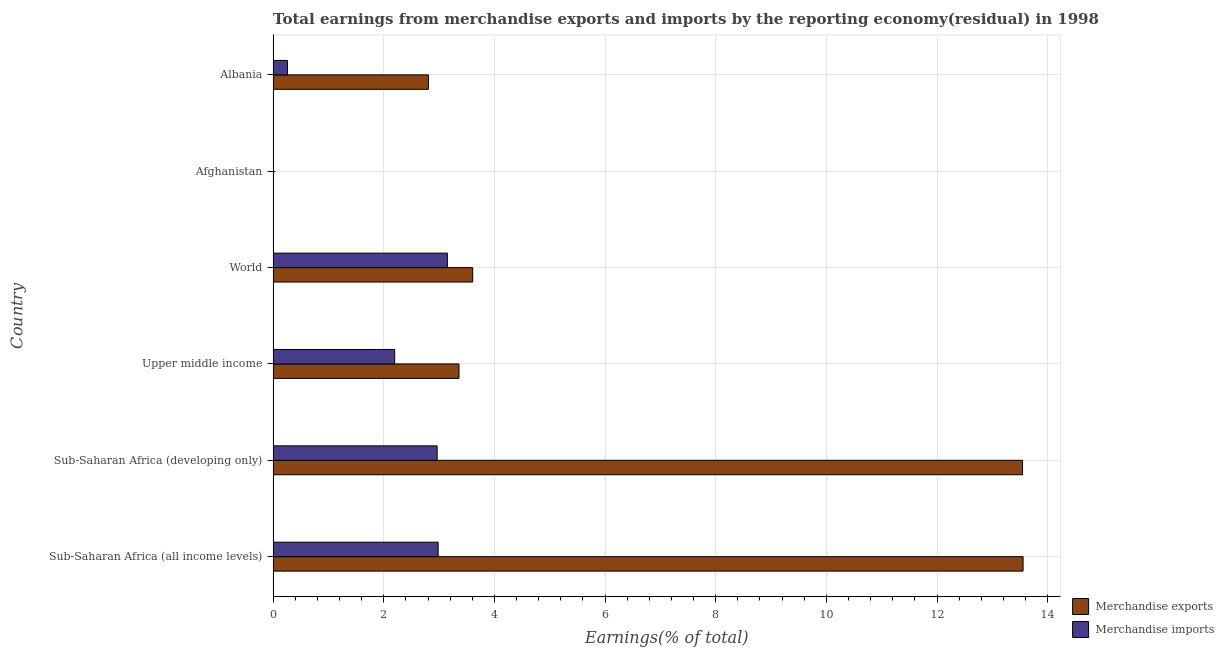How many different coloured bars are there?
Offer a very short reply. 2. Are the number of bars on each tick of the Y-axis equal?
Give a very brief answer. No. How many bars are there on the 4th tick from the top?
Provide a short and direct response. 2. How many bars are there on the 1st tick from the bottom?
Provide a succinct answer. 2. In how many cases, is the number of bars for a given country not equal to the number of legend labels?
Provide a short and direct response. 1. What is the earnings from merchandise imports in Sub-Saharan Africa (all income levels)?
Make the answer very short. 2.98. Across all countries, what is the maximum earnings from merchandise imports?
Keep it short and to the point. 3.15. What is the total earnings from merchandise exports in the graph?
Give a very brief answer. 36.88. What is the difference between the earnings from merchandise exports in Albania and that in World?
Offer a very short reply. -0.8. What is the difference between the earnings from merchandise exports in Sub-Saharan Africa (developing only) and the earnings from merchandise imports in Afghanistan?
Your answer should be very brief. 13.55. What is the average earnings from merchandise imports per country?
Keep it short and to the point. 1.93. What is the difference between the earnings from merchandise exports and earnings from merchandise imports in Sub-Saharan Africa (all income levels)?
Offer a terse response. 10.57. In how many countries, is the earnings from merchandise imports greater than 1.2000000000000002 %?
Offer a terse response. 4. What is the ratio of the earnings from merchandise imports in Sub-Saharan Africa (developing only) to that in Upper middle income?
Your answer should be very brief. 1.35. Is the earnings from merchandise exports in Albania less than that in World?
Your answer should be very brief. Yes. Is the difference between the earnings from merchandise imports in Albania and World greater than the difference between the earnings from merchandise exports in Albania and World?
Provide a short and direct response. No. What is the difference between the highest and the second highest earnings from merchandise exports?
Your answer should be very brief. 0.01. What is the difference between the highest and the lowest earnings from merchandise imports?
Provide a succinct answer. 3.15. What is the difference between two consecutive major ticks on the X-axis?
Ensure brevity in your answer.  2. Are the values on the major ticks of X-axis written in scientific E-notation?
Give a very brief answer. No. How are the legend labels stacked?
Your answer should be very brief. Vertical. What is the title of the graph?
Give a very brief answer. Total earnings from merchandise exports and imports by the reporting economy(residual) in 1998. Does "Male population" appear as one of the legend labels in the graph?
Make the answer very short. No. What is the label or title of the X-axis?
Provide a short and direct response. Earnings(% of total). What is the Earnings(% of total) of Merchandise exports in Sub-Saharan Africa (all income levels)?
Offer a terse response. 13.56. What is the Earnings(% of total) of Merchandise imports in Sub-Saharan Africa (all income levels)?
Provide a short and direct response. 2.98. What is the Earnings(% of total) in Merchandise exports in Sub-Saharan Africa (developing only)?
Your response must be concise. 13.55. What is the Earnings(% of total) of Merchandise imports in Sub-Saharan Africa (developing only)?
Your response must be concise. 2.96. What is the Earnings(% of total) in Merchandise exports in Upper middle income?
Offer a terse response. 3.36. What is the Earnings(% of total) of Merchandise imports in Upper middle income?
Give a very brief answer. 2.2. What is the Earnings(% of total) in Merchandise exports in World?
Provide a succinct answer. 3.61. What is the Earnings(% of total) of Merchandise imports in World?
Provide a succinct answer. 3.15. What is the Earnings(% of total) of Merchandise exports in Afghanistan?
Your answer should be very brief. 0. What is the Earnings(% of total) in Merchandise imports in Afghanistan?
Your response must be concise. 1.09007268250399e-8. What is the Earnings(% of total) of Merchandise exports in Albania?
Offer a very short reply. 2.81. What is the Earnings(% of total) of Merchandise imports in Albania?
Your response must be concise. 0.26. Across all countries, what is the maximum Earnings(% of total) of Merchandise exports?
Offer a very short reply. 13.56. Across all countries, what is the maximum Earnings(% of total) in Merchandise imports?
Give a very brief answer. 3.15. Across all countries, what is the minimum Earnings(% of total) of Merchandise exports?
Offer a terse response. 0. Across all countries, what is the minimum Earnings(% of total) of Merchandise imports?
Provide a succinct answer. 1.09007268250399e-8. What is the total Earnings(% of total) of Merchandise exports in the graph?
Make the answer very short. 36.88. What is the total Earnings(% of total) in Merchandise imports in the graph?
Your answer should be compact. 11.56. What is the difference between the Earnings(% of total) of Merchandise imports in Sub-Saharan Africa (all income levels) and that in Sub-Saharan Africa (developing only)?
Provide a short and direct response. 0.02. What is the difference between the Earnings(% of total) of Merchandise exports in Sub-Saharan Africa (all income levels) and that in Upper middle income?
Your answer should be very brief. 10.2. What is the difference between the Earnings(% of total) of Merchandise imports in Sub-Saharan Africa (all income levels) and that in Upper middle income?
Your answer should be very brief. 0.79. What is the difference between the Earnings(% of total) in Merchandise exports in Sub-Saharan Africa (all income levels) and that in World?
Keep it short and to the point. 9.95. What is the difference between the Earnings(% of total) of Merchandise imports in Sub-Saharan Africa (all income levels) and that in World?
Provide a succinct answer. -0.17. What is the difference between the Earnings(% of total) in Merchandise imports in Sub-Saharan Africa (all income levels) and that in Afghanistan?
Your answer should be compact. 2.98. What is the difference between the Earnings(% of total) in Merchandise exports in Sub-Saharan Africa (all income levels) and that in Albania?
Give a very brief answer. 10.75. What is the difference between the Earnings(% of total) of Merchandise imports in Sub-Saharan Africa (all income levels) and that in Albania?
Offer a very short reply. 2.72. What is the difference between the Earnings(% of total) of Merchandise exports in Sub-Saharan Africa (developing only) and that in Upper middle income?
Offer a very short reply. 10.19. What is the difference between the Earnings(% of total) of Merchandise imports in Sub-Saharan Africa (developing only) and that in Upper middle income?
Give a very brief answer. 0.77. What is the difference between the Earnings(% of total) of Merchandise exports in Sub-Saharan Africa (developing only) and that in World?
Keep it short and to the point. 9.94. What is the difference between the Earnings(% of total) in Merchandise imports in Sub-Saharan Africa (developing only) and that in World?
Your response must be concise. -0.18. What is the difference between the Earnings(% of total) of Merchandise imports in Sub-Saharan Africa (developing only) and that in Afghanistan?
Your answer should be compact. 2.96. What is the difference between the Earnings(% of total) in Merchandise exports in Sub-Saharan Africa (developing only) and that in Albania?
Ensure brevity in your answer.  10.74. What is the difference between the Earnings(% of total) in Merchandise imports in Sub-Saharan Africa (developing only) and that in Albania?
Make the answer very short. 2.71. What is the difference between the Earnings(% of total) in Merchandise exports in Upper middle income and that in World?
Offer a very short reply. -0.25. What is the difference between the Earnings(% of total) in Merchandise imports in Upper middle income and that in World?
Your response must be concise. -0.95. What is the difference between the Earnings(% of total) in Merchandise imports in Upper middle income and that in Afghanistan?
Ensure brevity in your answer.  2.2. What is the difference between the Earnings(% of total) of Merchandise exports in Upper middle income and that in Albania?
Ensure brevity in your answer.  0.55. What is the difference between the Earnings(% of total) of Merchandise imports in Upper middle income and that in Albania?
Offer a terse response. 1.94. What is the difference between the Earnings(% of total) in Merchandise imports in World and that in Afghanistan?
Your response must be concise. 3.15. What is the difference between the Earnings(% of total) of Merchandise exports in World and that in Albania?
Offer a terse response. 0.8. What is the difference between the Earnings(% of total) of Merchandise imports in World and that in Albania?
Your answer should be very brief. 2.89. What is the difference between the Earnings(% of total) of Merchandise imports in Afghanistan and that in Albania?
Provide a short and direct response. -0.26. What is the difference between the Earnings(% of total) of Merchandise exports in Sub-Saharan Africa (all income levels) and the Earnings(% of total) of Merchandise imports in Sub-Saharan Africa (developing only)?
Provide a succinct answer. 10.59. What is the difference between the Earnings(% of total) of Merchandise exports in Sub-Saharan Africa (all income levels) and the Earnings(% of total) of Merchandise imports in Upper middle income?
Give a very brief answer. 11.36. What is the difference between the Earnings(% of total) in Merchandise exports in Sub-Saharan Africa (all income levels) and the Earnings(% of total) in Merchandise imports in World?
Offer a very short reply. 10.41. What is the difference between the Earnings(% of total) in Merchandise exports in Sub-Saharan Africa (all income levels) and the Earnings(% of total) in Merchandise imports in Afghanistan?
Offer a very short reply. 13.56. What is the difference between the Earnings(% of total) in Merchandise exports in Sub-Saharan Africa (all income levels) and the Earnings(% of total) in Merchandise imports in Albania?
Offer a terse response. 13.3. What is the difference between the Earnings(% of total) in Merchandise exports in Sub-Saharan Africa (developing only) and the Earnings(% of total) in Merchandise imports in Upper middle income?
Keep it short and to the point. 11.35. What is the difference between the Earnings(% of total) in Merchandise exports in Sub-Saharan Africa (developing only) and the Earnings(% of total) in Merchandise imports in World?
Make the answer very short. 10.4. What is the difference between the Earnings(% of total) in Merchandise exports in Sub-Saharan Africa (developing only) and the Earnings(% of total) in Merchandise imports in Afghanistan?
Offer a very short reply. 13.55. What is the difference between the Earnings(% of total) in Merchandise exports in Sub-Saharan Africa (developing only) and the Earnings(% of total) in Merchandise imports in Albania?
Keep it short and to the point. 13.29. What is the difference between the Earnings(% of total) in Merchandise exports in Upper middle income and the Earnings(% of total) in Merchandise imports in World?
Offer a very short reply. 0.21. What is the difference between the Earnings(% of total) in Merchandise exports in Upper middle income and the Earnings(% of total) in Merchandise imports in Afghanistan?
Make the answer very short. 3.36. What is the difference between the Earnings(% of total) in Merchandise exports in Upper middle income and the Earnings(% of total) in Merchandise imports in Albania?
Your answer should be very brief. 3.1. What is the difference between the Earnings(% of total) in Merchandise exports in World and the Earnings(% of total) in Merchandise imports in Afghanistan?
Make the answer very short. 3.61. What is the difference between the Earnings(% of total) in Merchandise exports in World and the Earnings(% of total) in Merchandise imports in Albania?
Your response must be concise. 3.35. What is the average Earnings(% of total) in Merchandise exports per country?
Your response must be concise. 6.15. What is the average Earnings(% of total) in Merchandise imports per country?
Your response must be concise. 1.93. What is the difference between the Earnings(% of total) in Merchandise exports and Earnings(% of total) in Merchandise imports in Sub-Saharan Africa (all income levels)?
Your answer should be compact. 10.57. What is the difference between the Earnings(% of total) in Merchandise exports and Earnings(% of total) in Merchandise imports in Sub-Saharan Africa (developing only)?
Your response must be concise. 10.58. What is the difference between the Earnings(% of total) of Merchandise exports and Earnings(% of total) of Merchandise imports in Upper middle income?
Your answer should be compact. 1.16. What is the difference between the Earnings(% of total) in Merchandise exports and Earnings(% of total) in Merchandise imports in World?
Make the answer very short. 0.46. What is the difference between the Earnings(% of total) of Merchandise exports and Earnings(% of total) of Merchandise imports in Albania?
Give a very brief answer. 2.55. What is the ratio of the Earnings(% of total) of Merchandise imports in Sub-Saharan Africa (all income levels) to that in Sub-Saharan Africa (developing only)?
Keep it short and to the point. 1.01. What is the ratio of the Earnings(% of total) in Merchandise exports in Sub-Saharan Africa (all income levels) to that in Upper middle income?
Your answer should be very brief. 4.03. What is the ratio of the Earnings(% of total) of Merchandise imports in Sub-Saharan Africa (all income levels) to that in Upper middle income?
Offer a very short reply. 1.36. What is the ratio of the Earnings(% of total) in Merchandise exports in Sub-Saharan Africa (all income levels) to that in World?
Keep it short and to the point. 3.76. What is the ratio of the Earnings(% of total) of Merchandise imports in Sub-Saharan Africa (all income levels) to that in World?
Offer a very short reply. 0.95. What is the ratio of the Earnings(% of total) in Merchandise imports in Sub-Saharan Africa (all income levels) to that in Afghanistan?
Make the answer very short. 2.74e+08. What is the ratio of the Earnings(% of total) of Merchandise exports in Sub-Saharan Africa (all income levels) to that in Albania?
Your answer should be compact. 4.83. What is the ratio of the Earnings(% of total) of Merchandise imports in Sub-Saharan Africa (all income levels) to that in Albania?
Give a very brief answer. 11.49. What is the ratio of the Earnings(% of total) of Merchandise exports in Sub-Saharan Africa (developing only) to that in Upper middle income?
Offer a very short reply. 4.03. What is the ratio of the Earnings(% of total) of Merchandise imports in Sub-Saharan Africa (developing only) to that in Upper middle income?
Offer a terse response. 1.35. What is the ratio of the Earnings(% of total) in Merchandise exports in Sub-Saharan Africa (developing only) to that in World?
Provide a short and direct response. 3.75. What is the ratio of the Earnings(% of total) of Merchandise imports in Sub-Saharan Africa (developing only) to that in World?
Your answer should be very brief. 0.94. What is the ratio of the Earnings(% of total) of Merchandise imports in Sub-Saharan Africa (developing only) to that in Afghanistan?
Offer a very short reply. 2.72e+08. What is the ratio of the Earnings(% of total) in Merchandise exports in Sub-Saharan Africa (developing only) to that in Albania?
Provide a succinct answer. 4.83. What is the ratio of the Earnings(% of total) in Merchandise imports in Sub-Saharan Africa (developing only) to that in Albania?
Offer a terse response. 11.41. What is the ratio of the Earnings(% of total) of Merchandise exports in Upper middle income to that in World?
Make the answer very short. 0.93. What is the ratio of the Earnings(% of total) in Merchandise imports in Upper middle income to that in World?
Your response must be concise. 0.7. What is the ratio of the Earnings(% of total) in Merchandise imports in Upper middle income to that in Afghanistan?
Provide a short and direct response. 2.02e+08. What is the ratio of the Earnings(% of total) of Merchandise exports in Upper middle income to that in Albania?
Your answer should be compact. 1.2. What is the ratio of the Earnings(% of total) of Merchandise imports in Upper middle income to that in Albania?
Your answer should be compact. 8.46. What is the ratio of the Earnings(% of total) of Merchandise imports in World to that in Afghanistan?
Your response must be concise. 2.89e+08. What is the ratio of the Earnings(% of total) in Merchandise exports in World to that in Albania?
Provide a short and direct response. 1.29. What is the ratio of the Earnings(% of total) in Merchandise imports in World to that in Albania?
Offer a terse response. 12.13. What is the difference between the highest and the second highest Earnings(% of total) of Merchandise imports?
Ensure brevity in your answer.  0.17. What is the difference between the highest and the lowest Earnings(% of total) in Merchandise exports?
Offer a terse response. 13.56. What is the difference between the highest and the lowest Earnings(% of total) of Merchandise imports?
Offer a terse response. 3.15. 